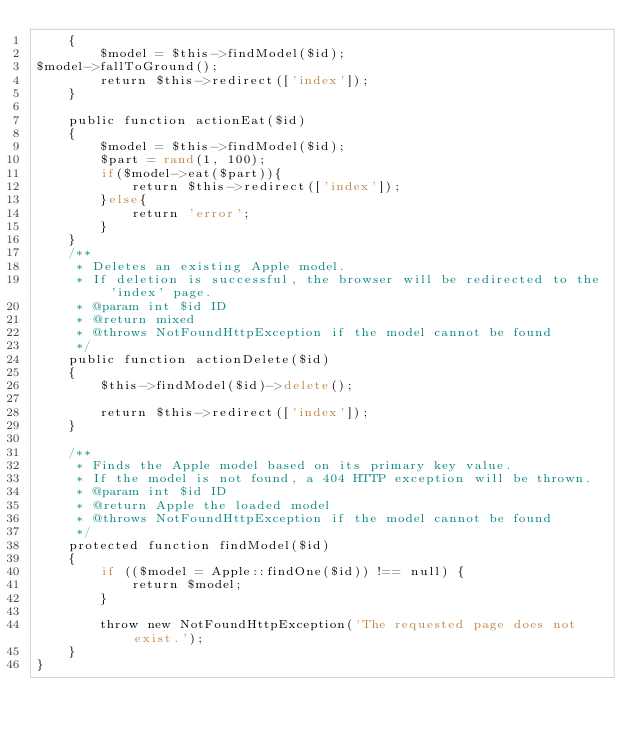Convert code to text. <code><loc_0><loc_0><loc_500><loc_500><_PHP_>    {
        $model = $this->findModel($id);
$model->fallToGround();
        return $this->redirect(['index']);
    }

    public function actionEat($id)
    {
        $model = $this->findModel($id);
        $part = rand(1, 100);
        if($model->eat($part)){
            return $this->redirect(['index']);
        }else{
            return 'error';
        }
    }
    /**
     * Deletes an existing Apple model.
     * If deletion is successful, the browser will be redirected to the 'index' page.
     * @param int $id ID
     * @return mixed
     * @throws NotFoundHttpException if the model cannot be found
     */
    public function actionDelete($id)
    {
        $this->findModel($id)->delete();

        return $this->redirect(['index']);
    }

    /**
     * Finds the Apple model based on its primary key value.
     * If the model is not found, a 404 HTTP exception will be thrown.
     * @param int $id ID
     * @return Apple the loaded model
     * @throws NotFoundHttpException if the model cannot be found
     */
    protected function findModel($id)
    {
        if (($model = Apple::findOne($id)) !== null) {
            return $model;
        }

        throw new NotFoundHttpException('The requested page does not exist.');
    }
}
</code> 